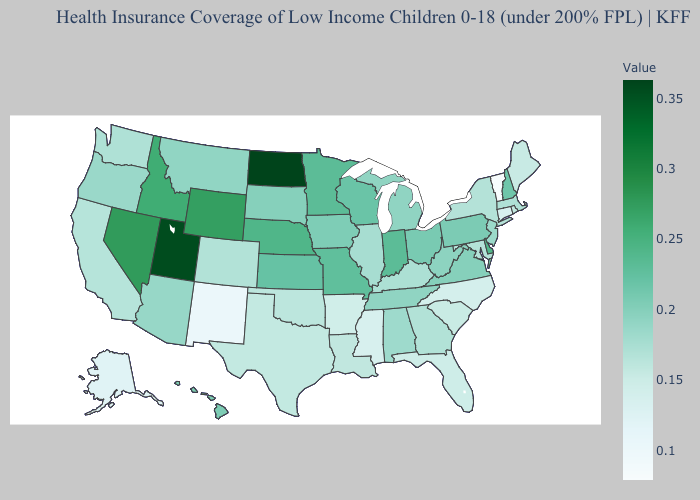Does New Jersey have the highest value in the USA?
Answer briefly. No. Which states have the highest value in the USA?
Concise answer only. North Dakota. Does Vermont have the lowest value in the USA?
Give a very brief answer. Yes. Among the states that border Pennsylvania , which have the lowest value?
Short answer required. Maryland, New York. 